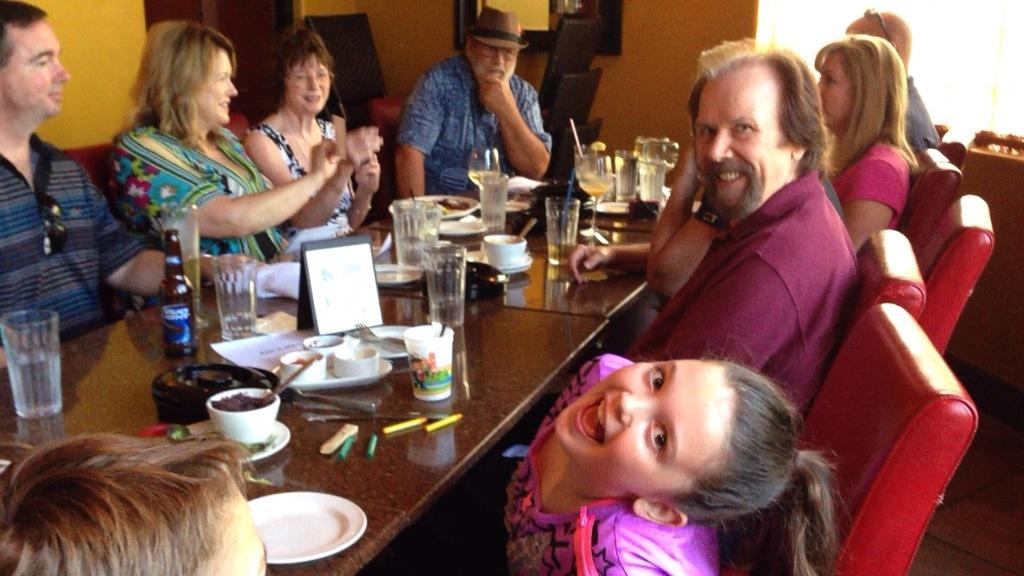What type of vehicle is present in the image? There is a car in the image. Can you describe the position of the person in relation to the car? The person is standing next to the car. What type of band is playing music in the image? There is no band present in the image; it only features a car and a person standing next to it. How many sides does the car have in the image? The question about the number of sides of the car is not relevant to the image, as cars are typically described in terms of their shape (e.g., sedan, SUV) rather than the number of sides. 